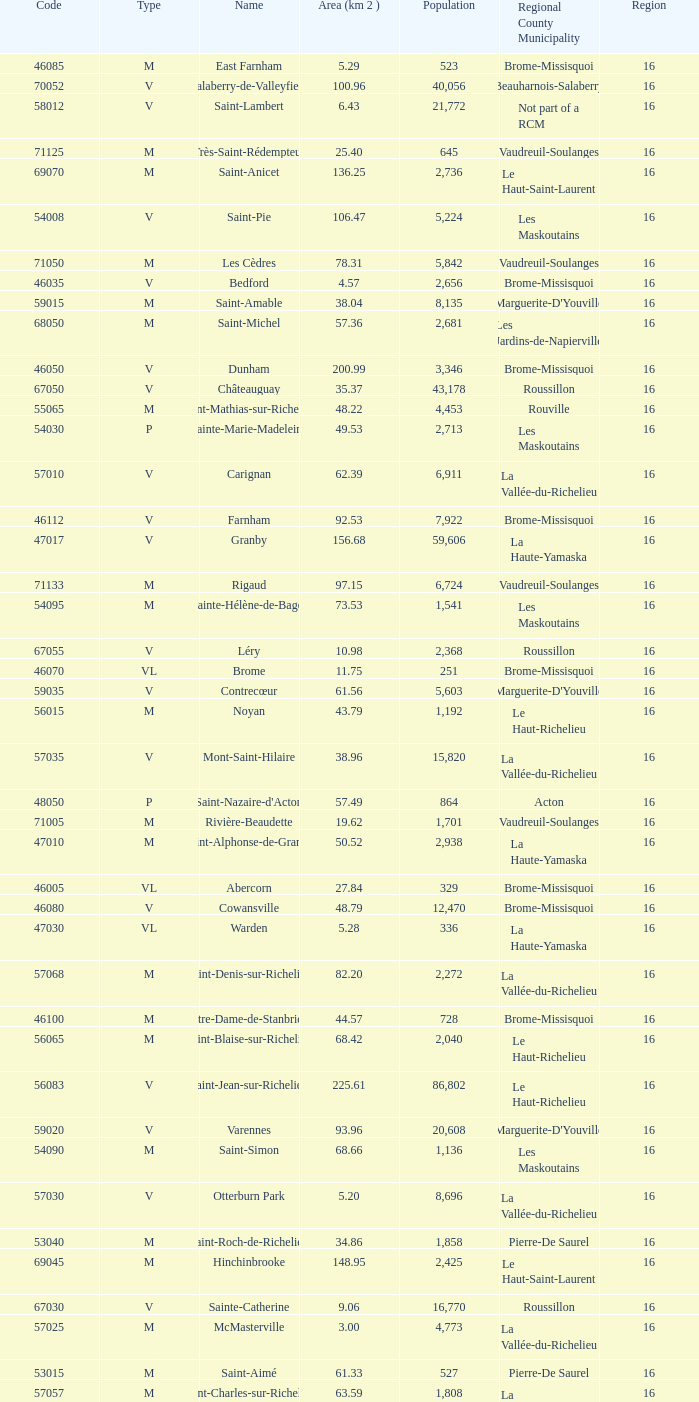What is the code for a Le Haut-Saint-Laurent municipality that has 16 or more regions? None. 